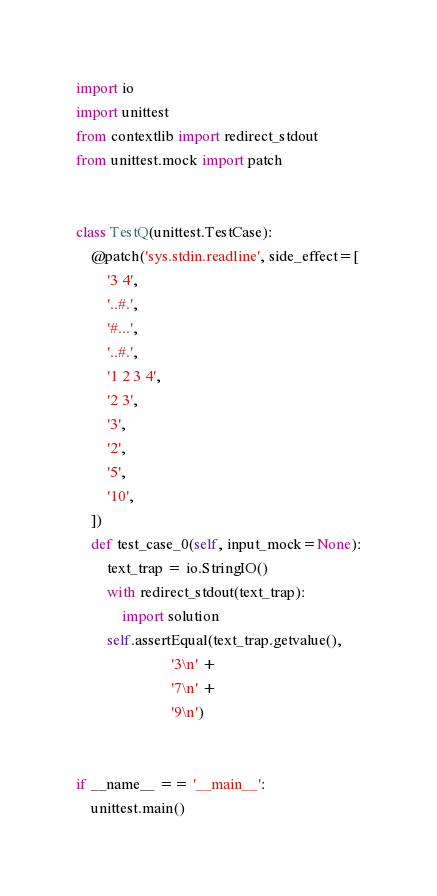Convert code to text. <code><loc_0><loc_0><loc_500><loc_500><_Python_>import io
import unittest
from contextlib import redirect_stdout
from unittest.mock import patch


class TestQ(unittest.TestCase):
    @patch('sys.stdin.readline', side_effect=[
        '3 4',
        '..#.',
        '#...',
        '..#.',
        '1 2 3 4',
        '2 3',
        '3',
        '2',
        '5',
        '10',
    ])
    def test_case_0(self, input_mock=None):
        text_trap = io.StringIO()
        with redirect_stdout(text_trap):
            import solution
        self.assertEqual(text_trap.getvalue(),
                         '3\n' +
                         '7\n' +
                         '9\n')


if __name__ == '__main__':
    unittest.main()
</code> 